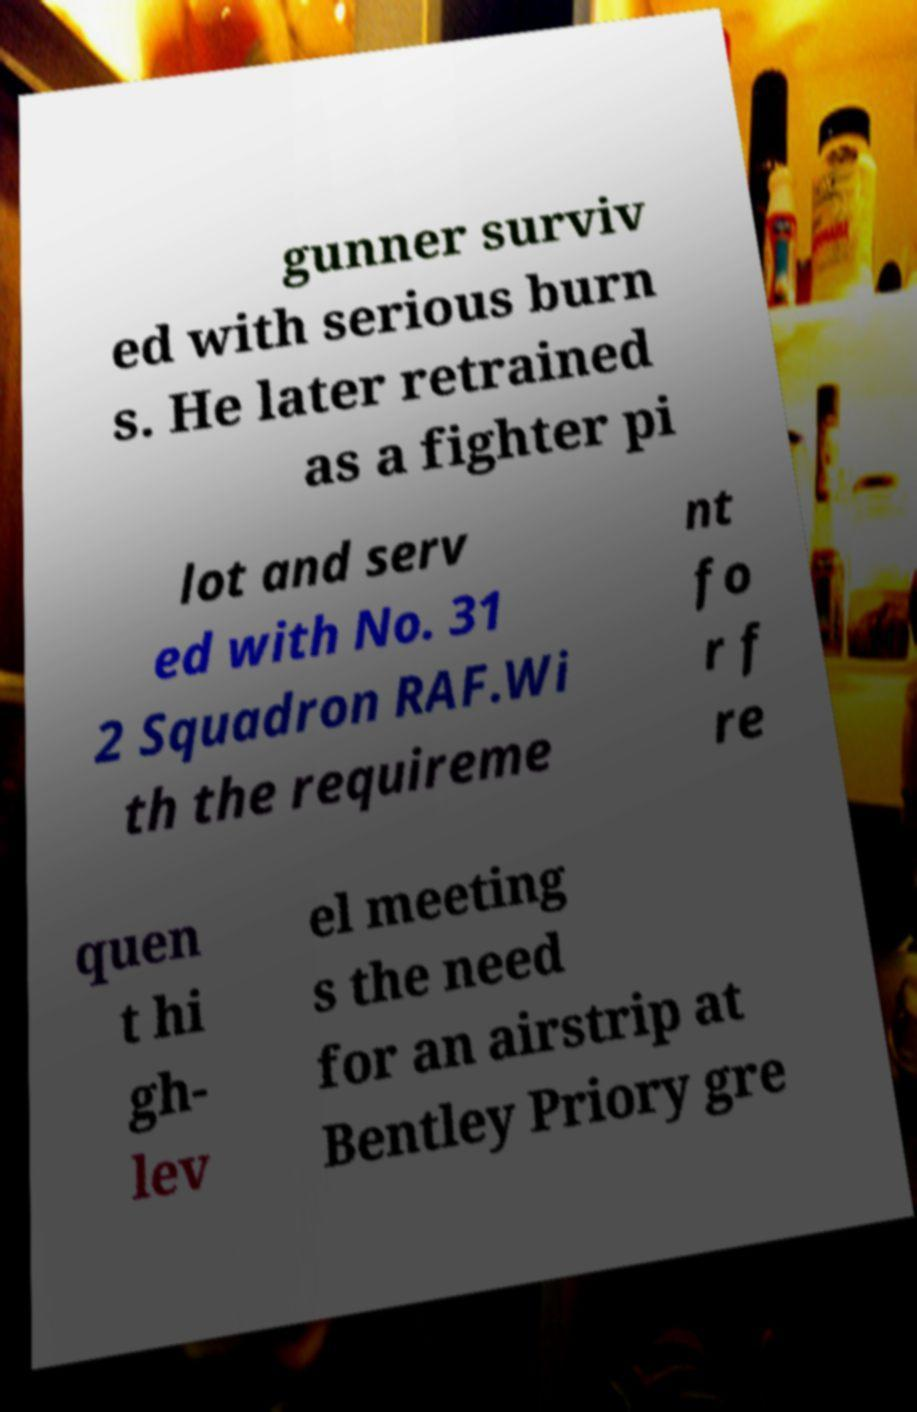Please read and relay the text visible in this image. What does it say? gunner surviv ed with serious burn s. He later retrained as a fighter pi lot and serv ed with No. 31 2 Squadron RAF.Wi th the requireme nt fo r f re quen t hi gh- lev el meeting s the need for an airstrip at Bentley Priory gre 